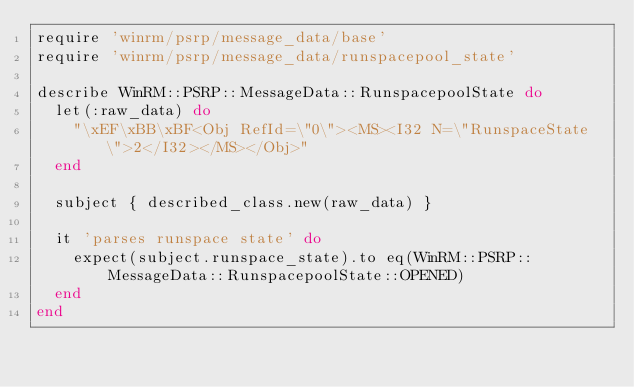Convert code to text. <code><loc_0><loc_0><loc_500><loc_500><_Ruby_>require 'winrm/psrp/message_data/base'
require 'winrm/psrp/message_data/runspacepool_state'

describe WinRM::PSRP::MessageData::RunspacepoolState do
  let(:raw_data) do
    "\xEF\xBB\xBF<Obj RefId=\"0\"><MS><I32 N=\"RunspaceState\">2</I32></MS></Obj>"
  end

  subject { described_class.new(raw_data) }

  it 'parses runspace state' do
    expect(subject.runspace_state).to eq(WinRM::PSRP::MessageData::RunspacepoolState::OPENED)
  end
end
</code> 